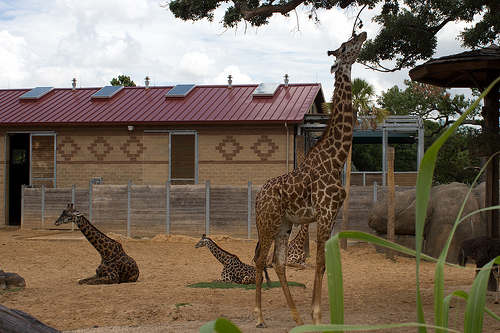What if the giraffes in the image were replaced by dragons? What a fantastical sight that would be! Imagine the serene setting of the zoo suddenly home to magnificent dragons. These mythical creatures, with their glistening scales and powerful wings, would create a scene straight out of a fantasy novel. The red-roofed building with its solar panels would now contrast sharply with the vibrant, possibly jewel-toned colors of the dragons. One dragon could be perched majestically on the roof, surveying its domain, while another lies gracefully on the ground where the giraffes once were. The dragons’ imposing size and grandeur would transform the tranquil enclosure into a spectacular realm of imagination and wonder. 